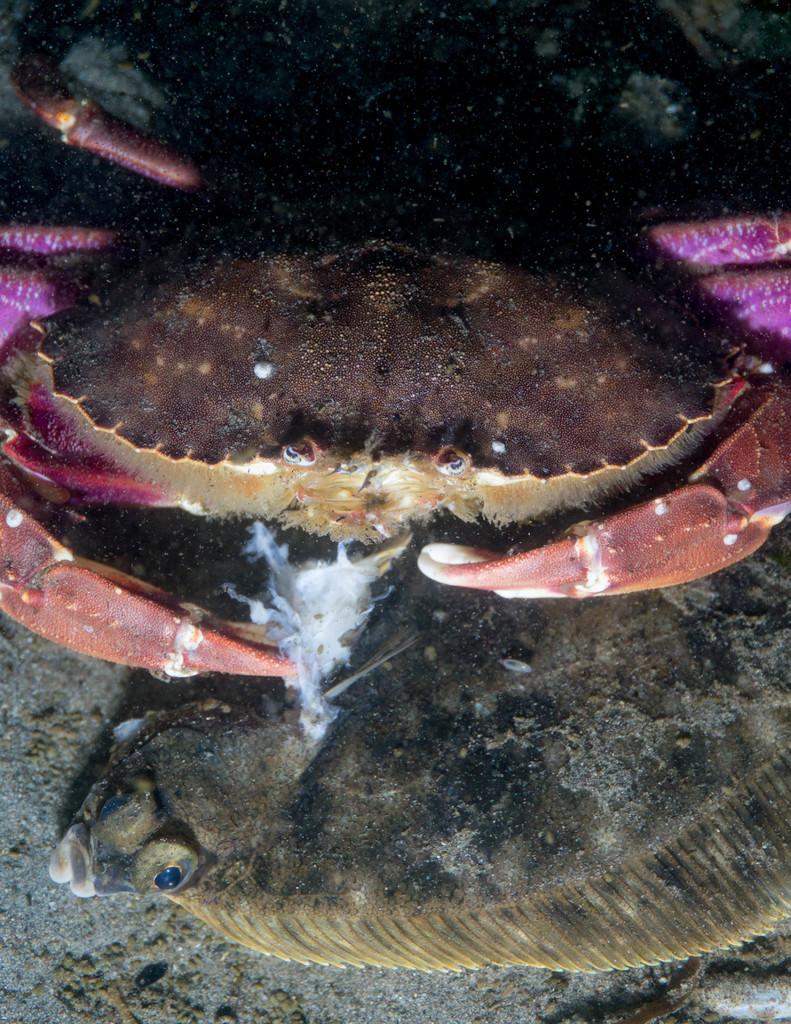Could you give a brief overview of what you see in this image? In this image we can see water animals in water. At the bottom of the image there is floor. 